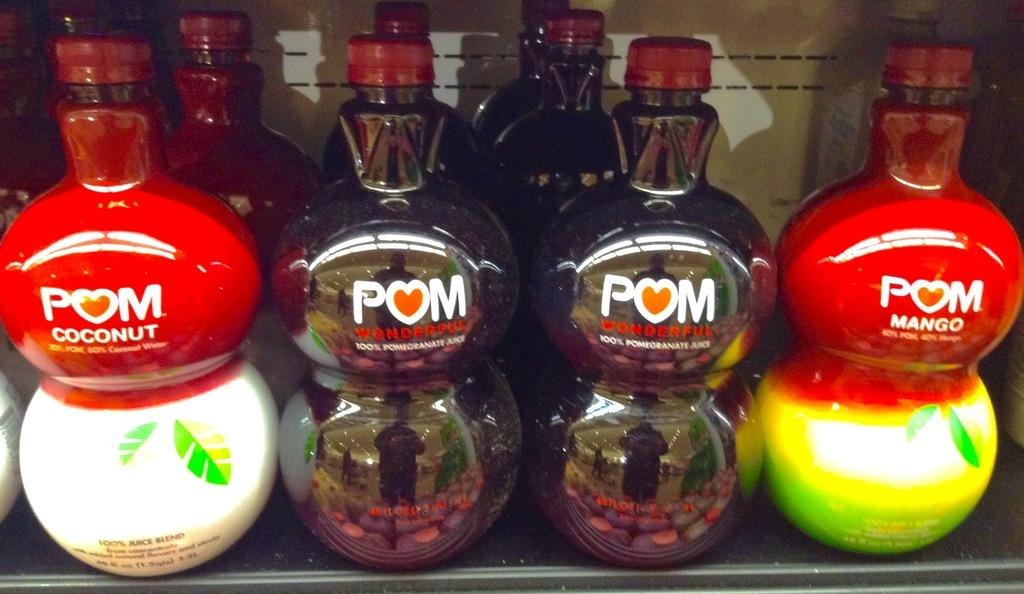What is the main subject of the image? The main subject of the image is a group of bottles. What can be observed about the caps of the bottles? The caps of the bottles have a red color. Where are the bottles located in the image? The bottles are on a rack. Can you see a volcano erupting in the background of the image? There is no volcano present in the image. Are the bottles being worn as stockings in the image? The bottles are not being worn as stockings; they are on a rack. 